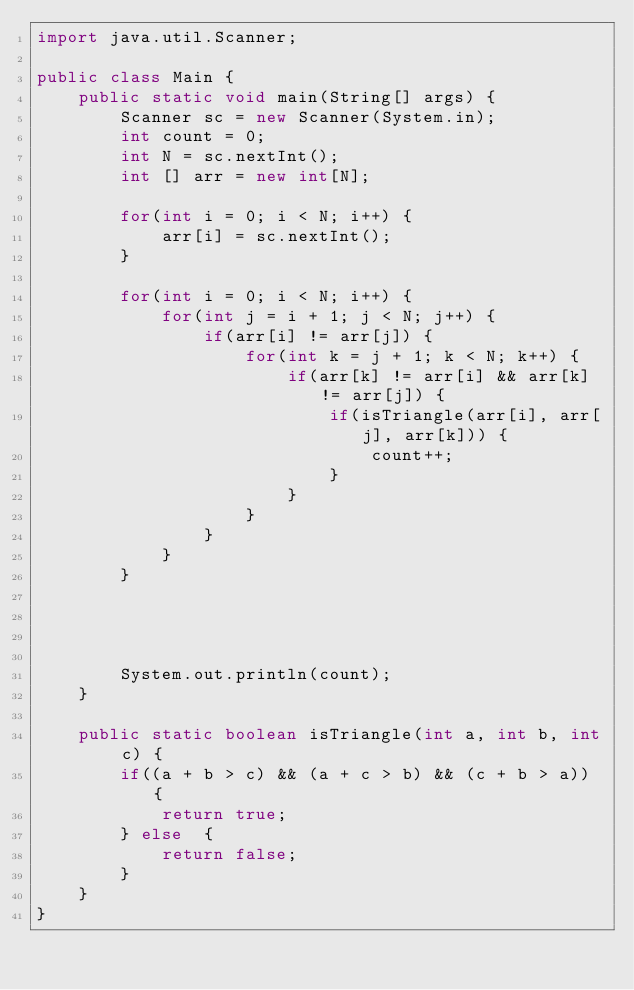Convert code to text. <code><loc_0><loc_0><loc_500><loc_500><_Java_>import java.util.Scanner;

public class Main {
    public static void main(String[] args) {
        Scanner sc = new Scanner(System.in);
        int count = 0;
        int N = sc.nextInt();
        int [] arr = new int[N];

        for(int i = 0; i < N; i++) {
            arr[i] = sc.nextInt();
        }

        for(int i = 0; i < N; i++) {
            for(int j = i + 1; j < N; j++) {
                if(arr[i] != arr[j]) {
                    for(int k = j + 1; k < N; k++) {
                        if(arr[k] != arr[i] && arr[k] != arr[j]) {
                            if(isTriangle(arr[i], arr[j], arr[k])) {
                                count++;
                            }
                        }
                    }
                }
            }
        }




        System.out.println(count);
    }

    public static boolean isTriangle(int a, int b, int c) {
        if((a + b > c) && (a + c > b) && (c + b > a)) {
            return true;
        } else  {
            return false;
        }
    }
}
</code> 